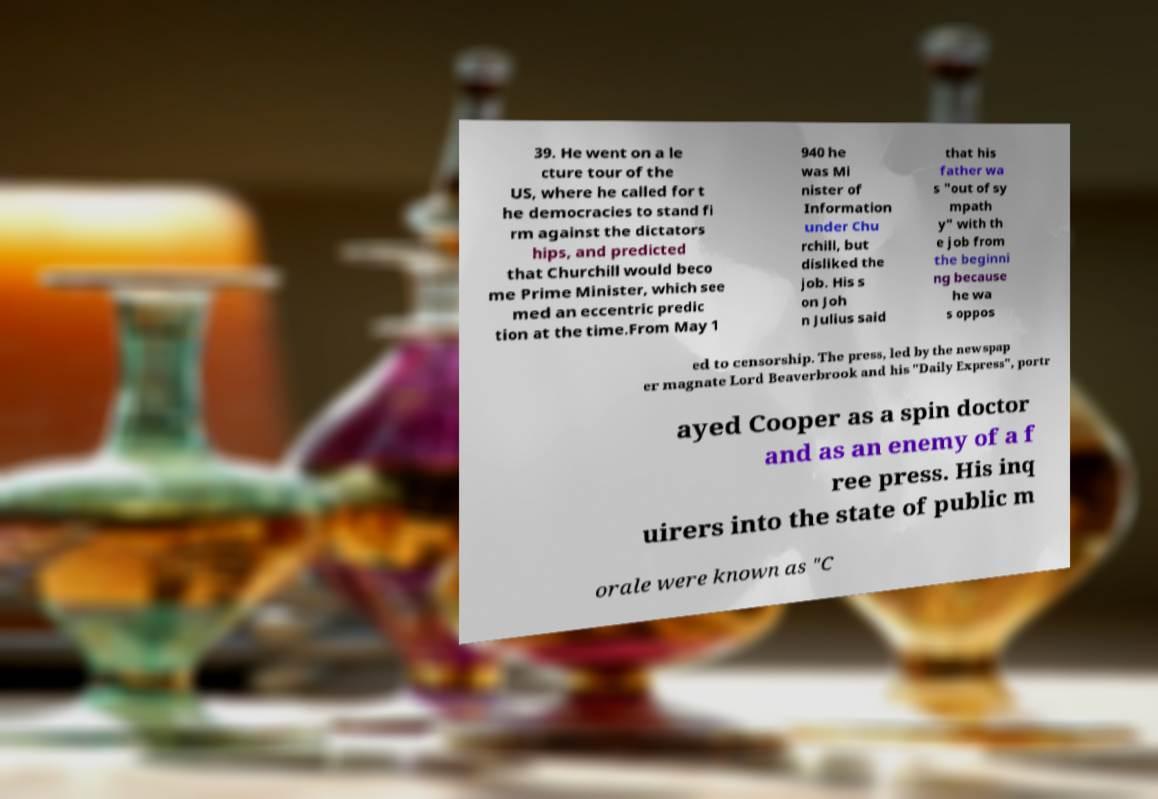There's text embedded in this image that I need extracted. Can you transcribe it verbatim? 39. He went on a le cture tour of the US, where he called for t he democracies to stand fi rm against the dictators hips, and predicted that Churchill would beco me Prime Minister, which see med an eccentric predic tion at the time.From May 1 940 he was Mi nister of Information under Chu rchill, but disliked the job. His s on Joh n Julius said that his father wa s "out of sy mpath y" with th e job from the beginni ng because he wa s oppos ed to censorship. The press, led by the newspap er magnate Lord Beaverbrook and his "Daily Express", portr ayed Cooper as a spin doctor and as an enemy of a f ree press. His inq uirers into the state of public m orale were known as "C 